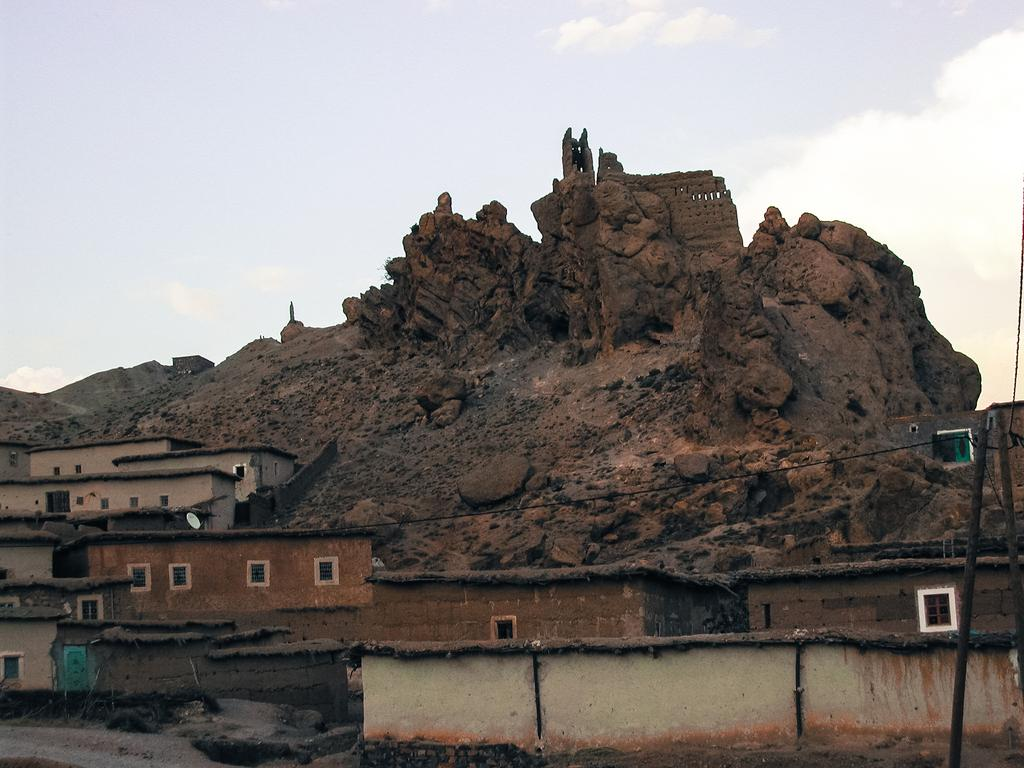What type of structures are present in the image? There are buildings with windows in the image. What can be seen in the background of the image? There is a rock hill and the sky visible in the background of the image. How many trucks are parked on the rock hill in the image? There are no trucks present in the image; it features buildings with windows and a rock hill in the background. 